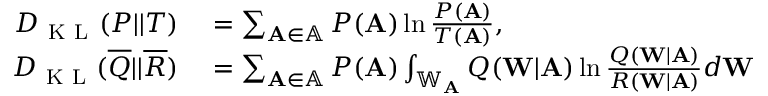<formula> <loc_0><loc_0><loc_500><loc_500>\begin{array} { r l } { D _ { K L } ( P | | T ) } & = \sum _ { A \in \mathbb { A } } P ( A ) \ln \frac { P ( A ) } { T ( A ) } , } \\ { D _ { K L } ( \overline { Q } | | \overline { R } ) } & = \sum _ { A \in \mathbb { A } } P ( A ) \int _ { \mathbb { W } _ { A } } Q ( W | A ) \ln \frac { Q ( W | A ) } { R ( W | A ) } d W } \end{array}</formula> 